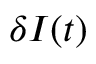<formula> <loc_0><loc_0><loc_500><loc_500>\delta I ( t )</formula> 